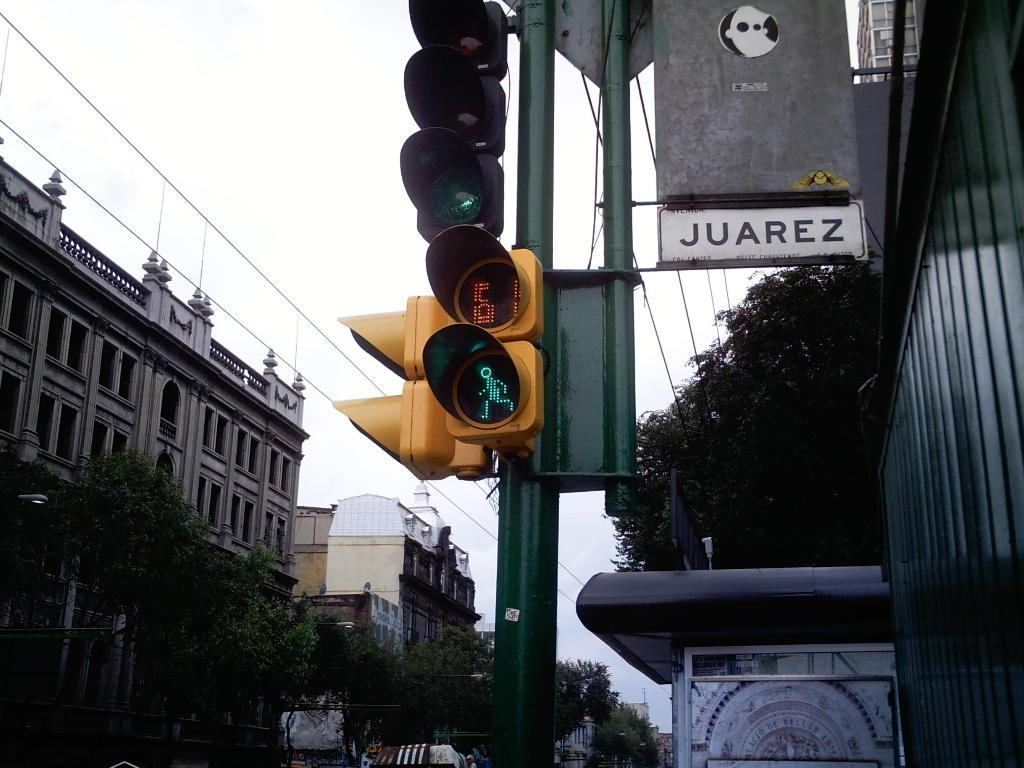<image>
Create a compact narrative representing the image presented. A sign for Juarez street hangs near a traffic and pedestrian-crossing light. 